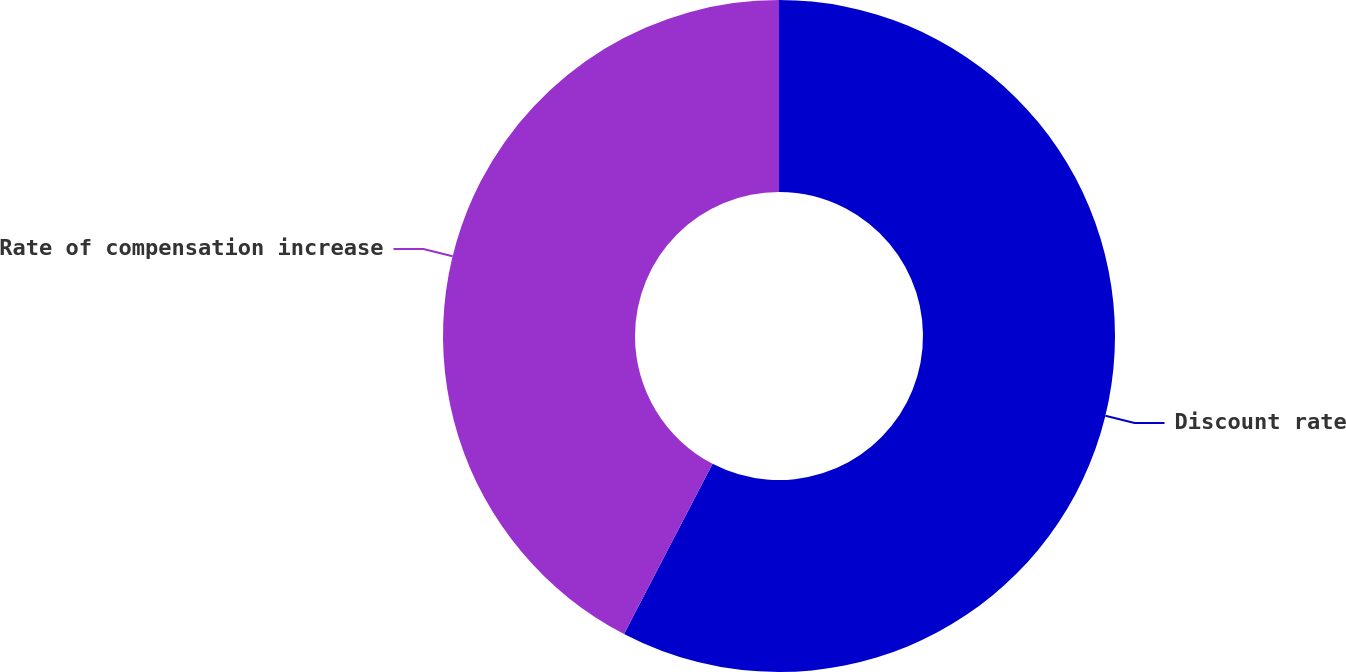Convert chart. <chart><loc_0><loc_0><loc_500><loc_500><pie_chart><fcel>Discount rate<fcel>Rate of compensation increase<nl><fcel>57.63%<fcel>42.37%<nl></chart> 